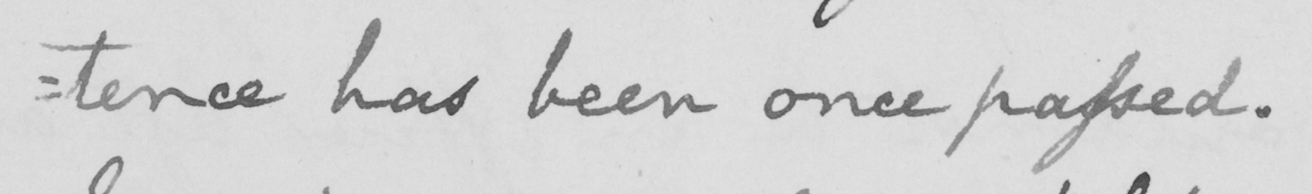What text is written in this handwritten line? :tence has been once passed. 